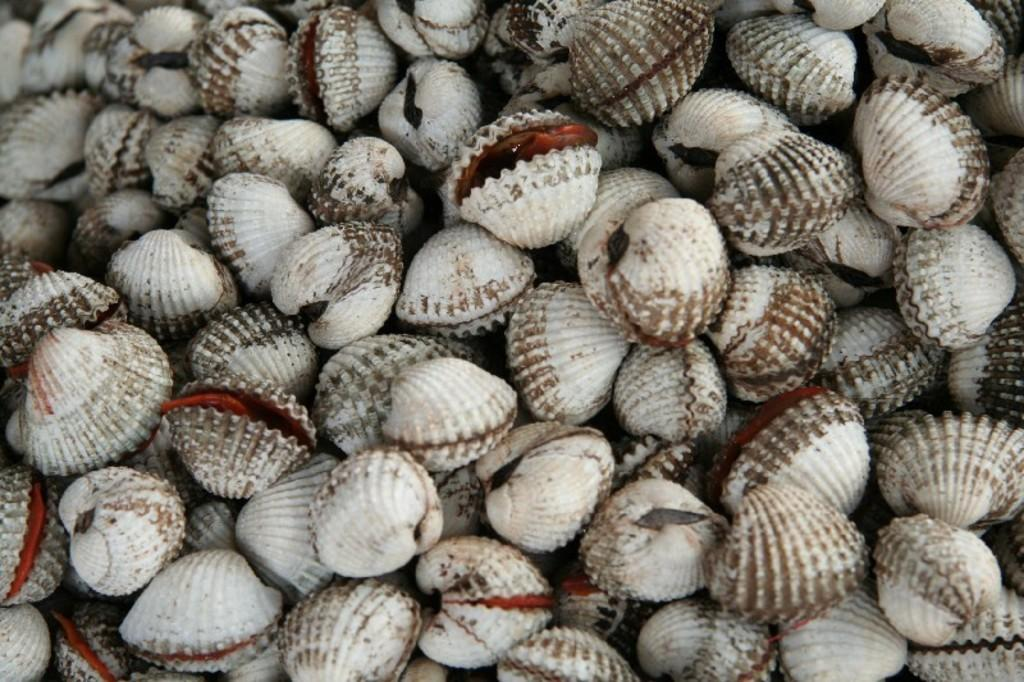What is the main subject of the image? The main subject of the image is a group of shells. What type of amusement can be seen in the image? There is no amusement present in the image; it features a group of shells. What type of crib is visible in the image? There is no crib present in the image; it features a group of shells. 